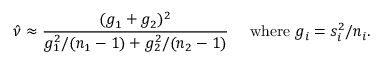<formula> <loc_0><loc_0><loc_500><loc_500>{ \hat { \nu } } \approx { \frac { ( g _ { 1 } + g _ { 2 } ) ^ { 2 } } { g _ { 1 } ^ { 2 } / ( n _ { 1 } - 1 ) + g _ { 2 } ^ { 2 } / ( n _ { 2 } - 1 ) } } \quad w h e r e g _ { i } = s _ { i } ^ { 2 } / n _ { i } .</formula> 